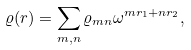Convert formula to latex. <formula><loc_0><loc_0><loc_500><loc_500>\varrho ( { r } ) = \sum _ { m , n } \varrho _ { m n } \omega ^ { m r _ { 1 } + n r _ { 2 } } ,</formula> 